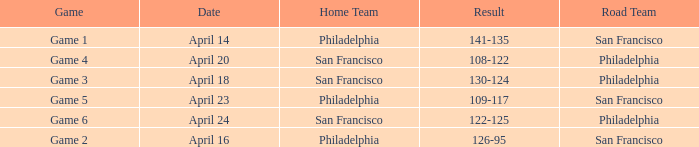What was the result of the April 16 game? 126-95. 